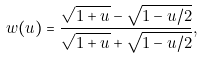Convert formula to latex. <formula><loc_0><loc_0><loc_500><loc_500>w ( u ) = \frac { \sqrt { 1 + u } - \sqrt { 1 - u / 2 } } { \sqrt { 1 + u } + \sqrt { 1 - u / 2 } } ,</formula> 